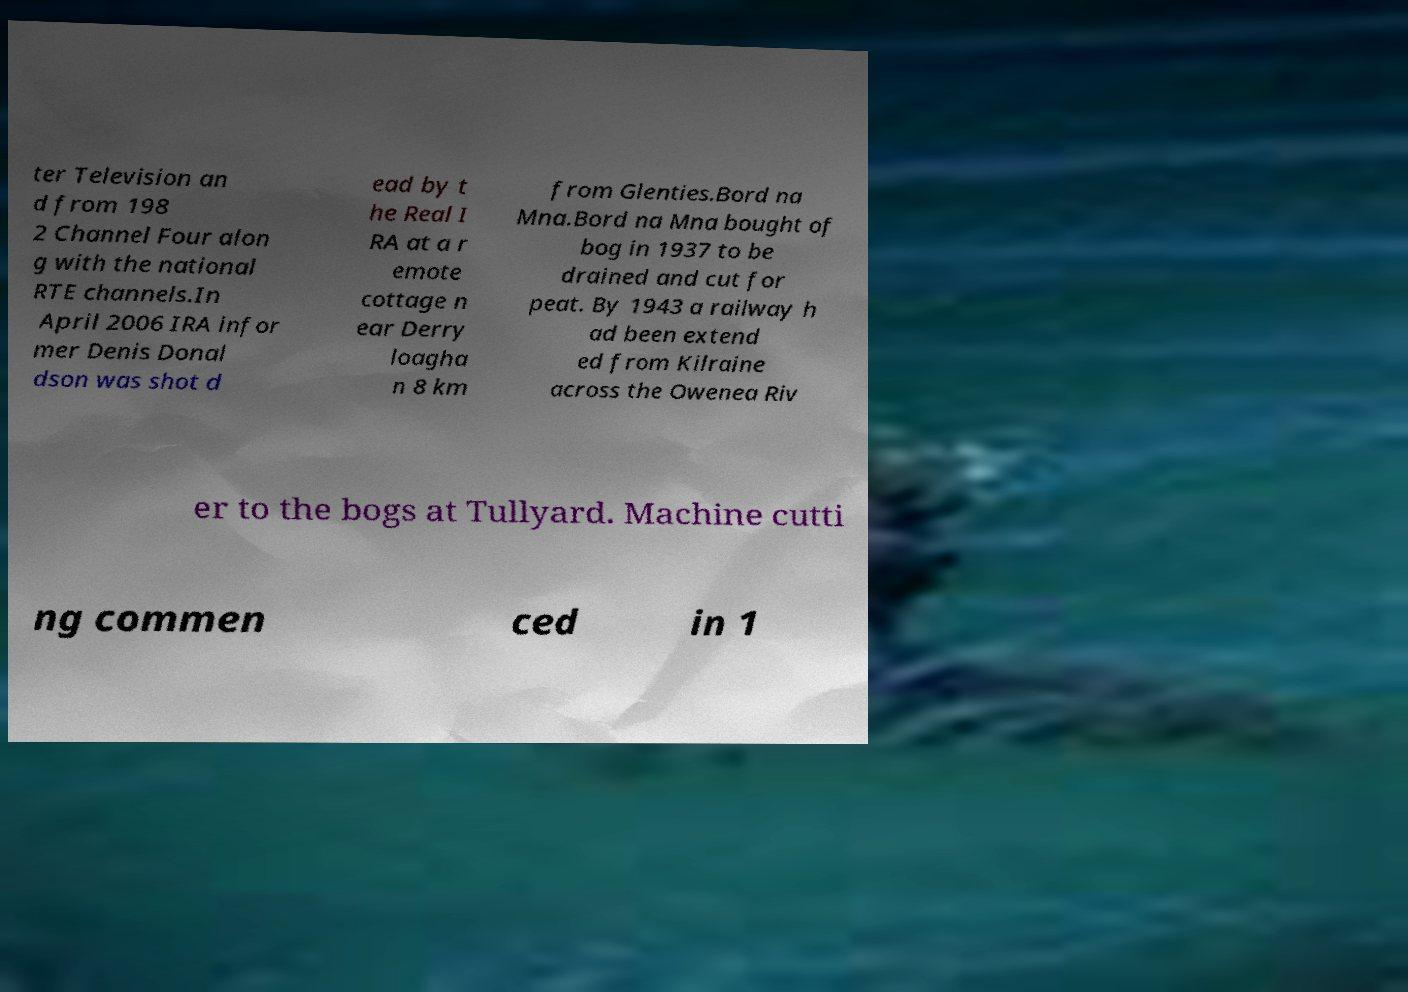Please read and relay the text visible in this image. What does it say? ter Television an d from 198 2 Channel Four alon g with the national RTE channels.In April 2006 IRA infor mer Denis Donal dson was shot d ead by t he Real I RA at a r emote cottage n ear Derry loagha n 8 km from Glenties.Bord na Mna.Bord na Mna bought of bog in 1937 to be drained and cut for peat. By 1943 a railway h ad been extend ed from Kilraine across the Owenea Riv er to the bogs at Tullyard. Machine cutti ng commen ced in 1 